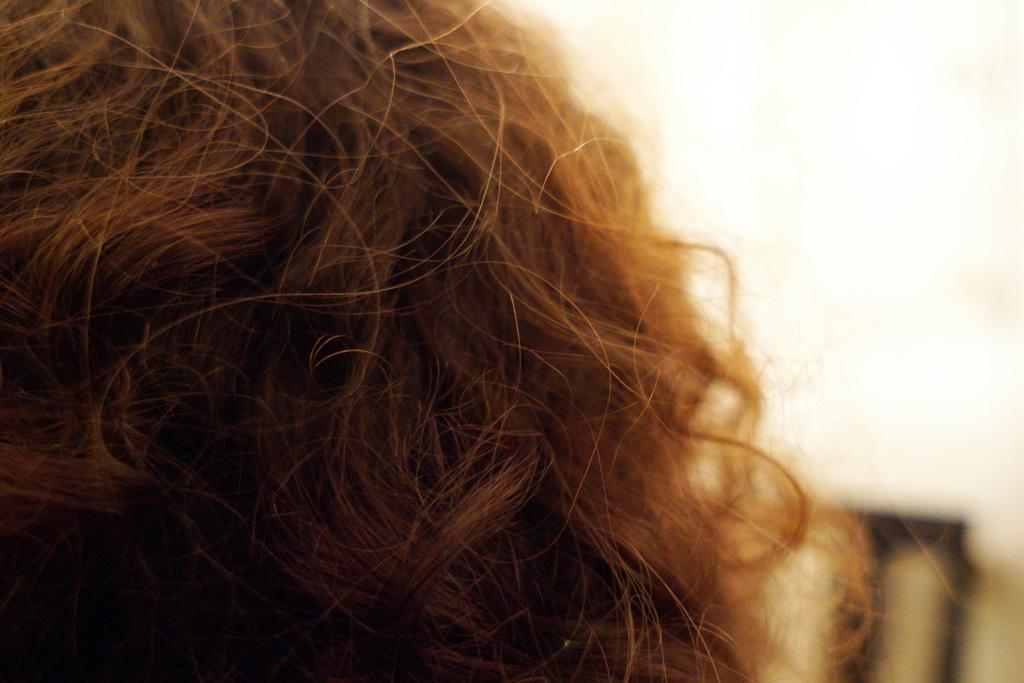What is located on the left side of the image? There is a hair of a person on the left side of the image. What can be seen in the background of the image? There is an object in the background of the image. What color is the background of the image? The background is white in color. What type of cave can be seen in the background of the image? There is no cave present in the image; the background is white with an object in it. 